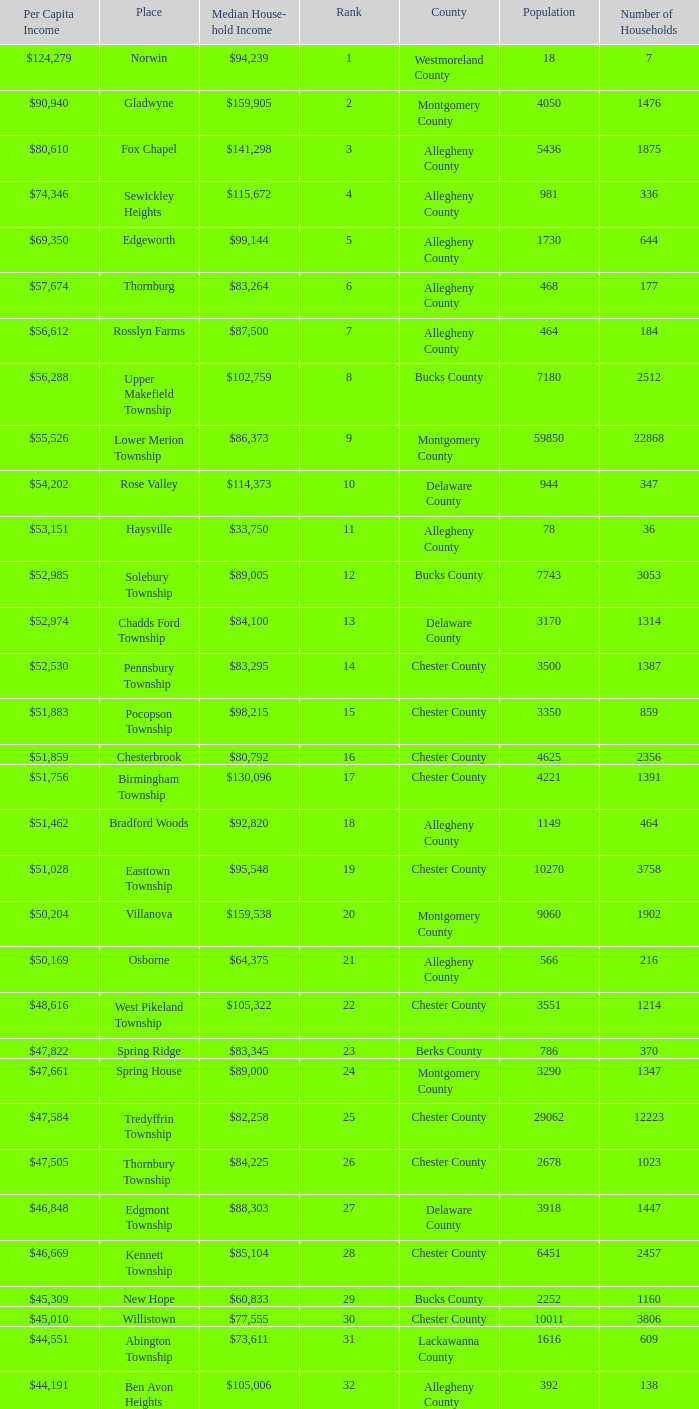Which place has a rank of 71? Wyomissing. 